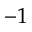Convert formula to latex. <formula><loc_0><loc_0><loc_500><loc_500>- 1</formula> 